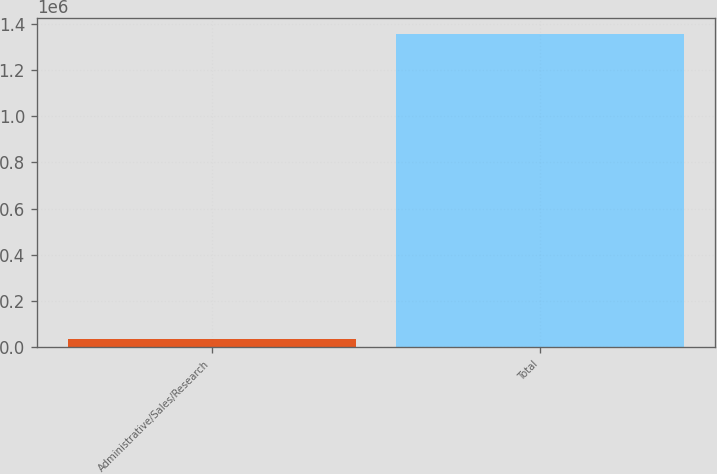Convert chart. <chart><loc_0><loc_0><loc_500><loc_500><bar_chart><fcel>Administrative/Sales/Research<fcel>Total<nl><fcel>34000<fcel>1.356e+06<nl></chart> 